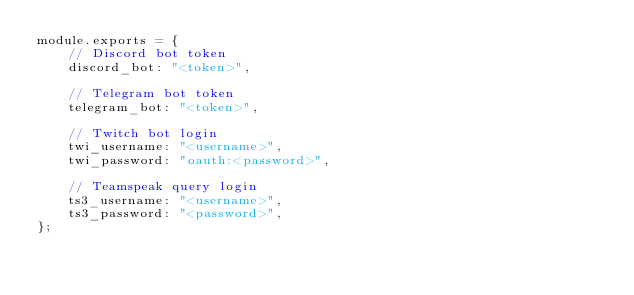<code> <loc_0><loc_0><loc_500><loc_500><_JavaScript_>module.exports = {
    // Discord bot token 
    discord_bot: "<token>",

    // Telegram bot token
    telegram_bot: "<token>",

    // Twitch bot login
    twi_username: "<username>",
    twi_password: "oauth:<password>",

    // Teamspeak query login
    ts3_username: "<username>",
    ts3_password: "<password>",
};</code> 